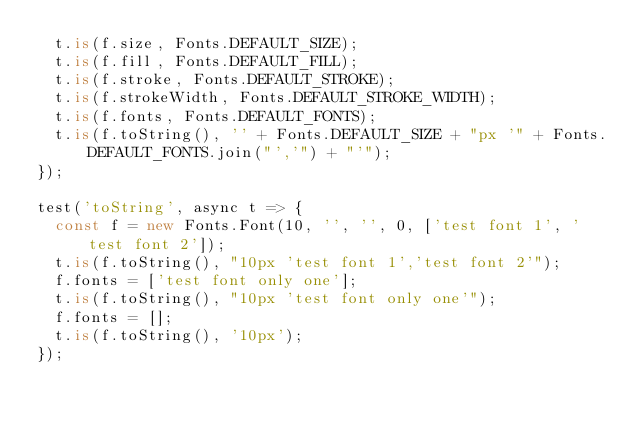Convert code to text. <code><loc_0><loc_0><loc_500><loc_500><_TypeScript_>  t.is(f.size, Fonts.DEFAULT_SIZE);
  t.is(f.fill, Fonts.DEFAULT_FILL);
  t.is(f.stroke, Fonts.DEFAULT_STROKE);
  t.is(f.strokeWidth, Fonts.DEFAULT_STROKE_WIDTH);
  t.is(f.fonts, Fonts.DEFAULT_FONTS);
  t.is(f.toString(), '' + Fonts.DEFAULT_SIZE + "px '" + Fonts.DEFAULT_FONTS.join("','") + "'");
});

test('toString', async t => {
  const f = new Fonts.Font(10, '', '', 0, ['test font 1', 'test font 2']);
  t.is(f.toString(), "10px 'test font 1','test font 2'");
  f.fonts = ['test font only one'];
  t.is(f.toString(), "10px 'test font only one'");
  f.fonts = [];
  t.is(f.toString(), '10px');
});
</code> 